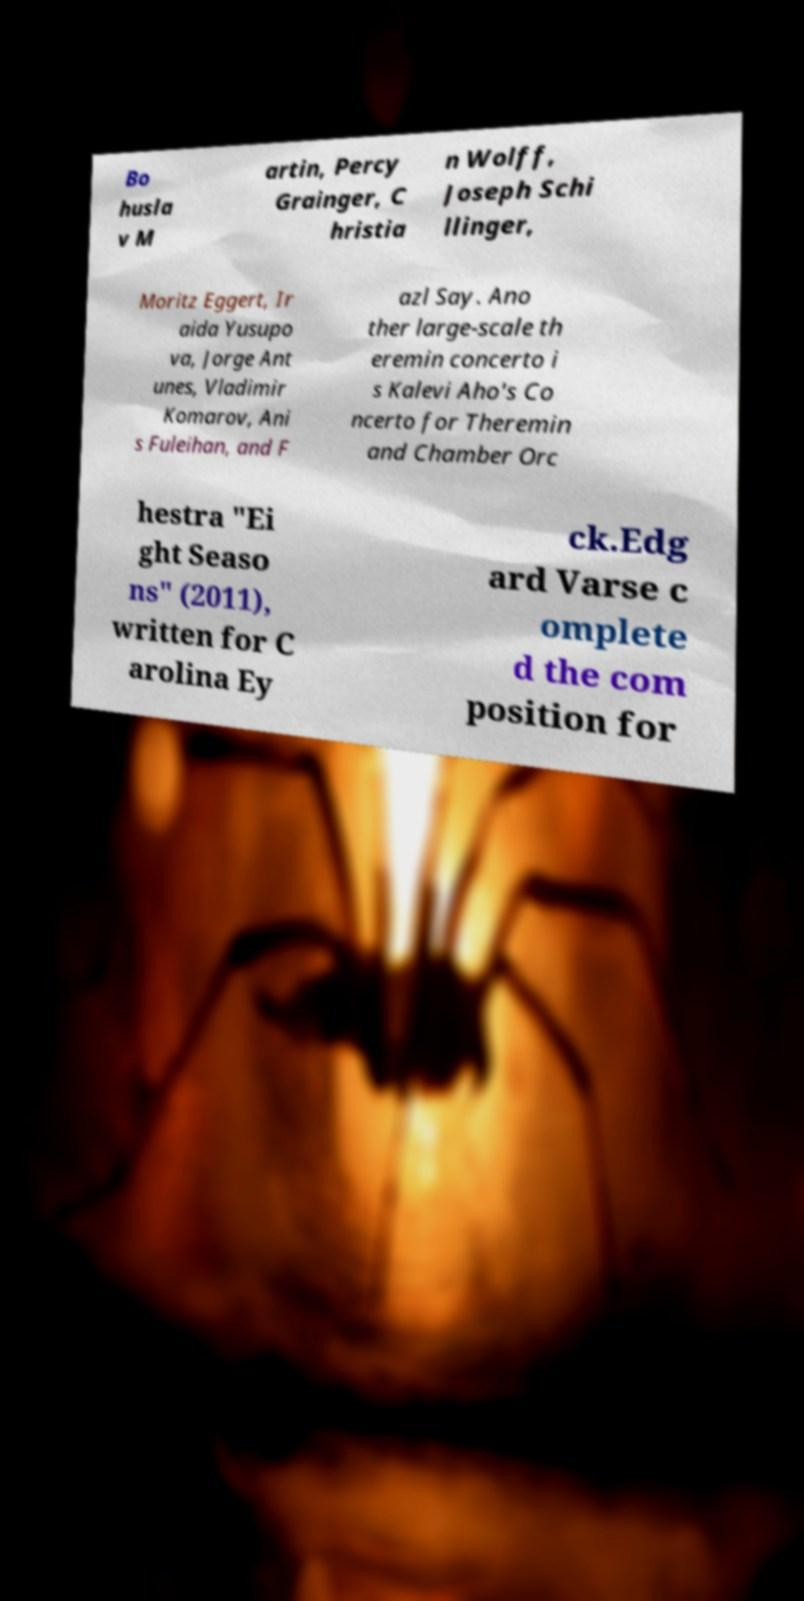I need the written content from this picture converted into text. Can you do that? Bo husla v M artin, Percy Grainger, C hristia n Wolff, Joseph Schi llinger, Moritz Eggert, Ir aida Yusupo va, Jorge Ant unes, Vladimir Komarov, Ani s Fuleihan, and F azl Say. Ano ther large-scale th eremin concerto i s Kalevi Aho's Co ncerto for Theremin and Chamber Orc hestra "Ei ght Seaso ns" (2011), written for C arolina Ey ck.Edg ard Varse c omplete d the com position for 